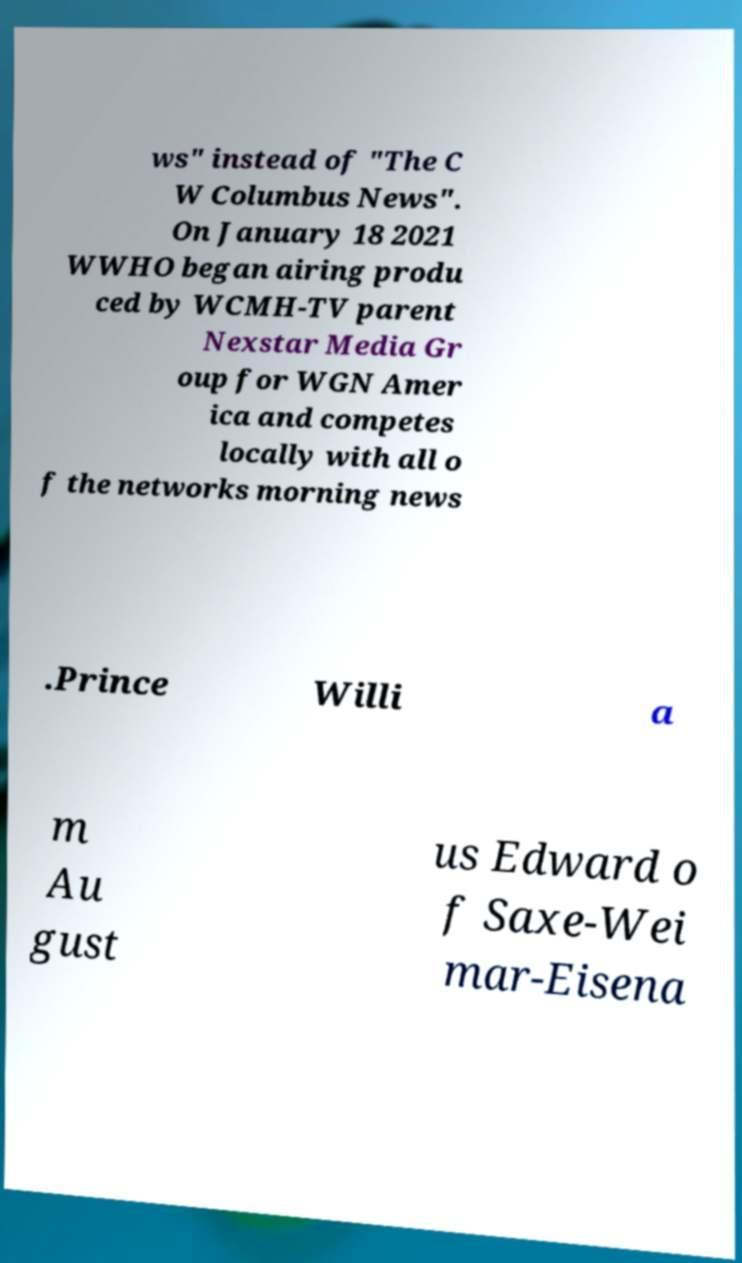What messages or text are displayed in this image? I need them in a readable, typed format. ws" instead of "The C W Columbus News". On January 18 2021 WWHO began airing produ ced by WCMH-TV parent Nexstar Media Gr oup for WGN Amer ica and competes locally with all o f the networks morning news .Prince Willi a m Au gust us Edward o f Saxe-Wei mar-Eisena 